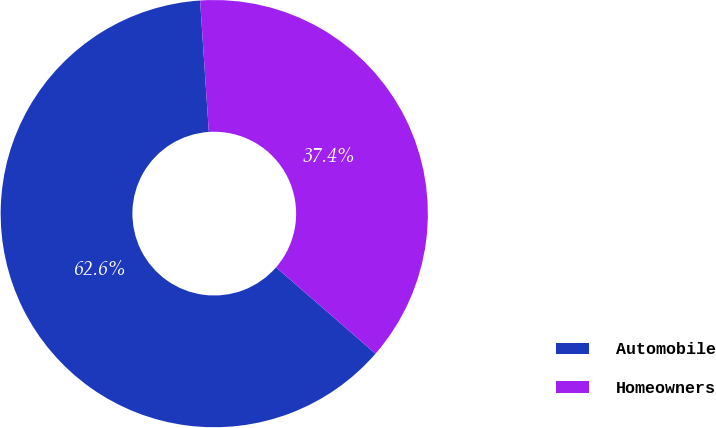Convert chart to OTSL. <chart><loc_0><loc_0><loc_500><loc_500><pie_chart><fcel>Automobile<fcel>Homeowners<nl><fcel>62.56%<fcel>37.44%<nl></chart> 